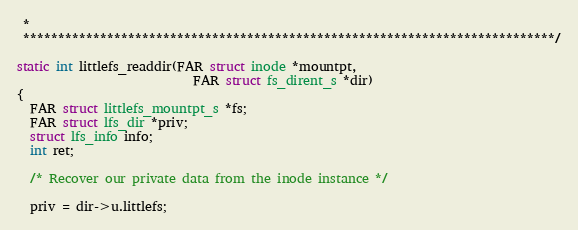<code> <loc_0><loc_0><loc_500><loc_500><_C_> *
 ****************************************************************************/

static int littlefs_readdir(FAR struct inode *mountpt,
                            FAR struct fs_dirent_s *dir)
{
  FAR struct littlefs_mountpt_s *fs;
  FAR struct lfs_dir *priv;
  struct lfs_info info;
  int ret;

  /* Recover our private data from the inode instance */

  priv = dir->u.littlefs;</code> 